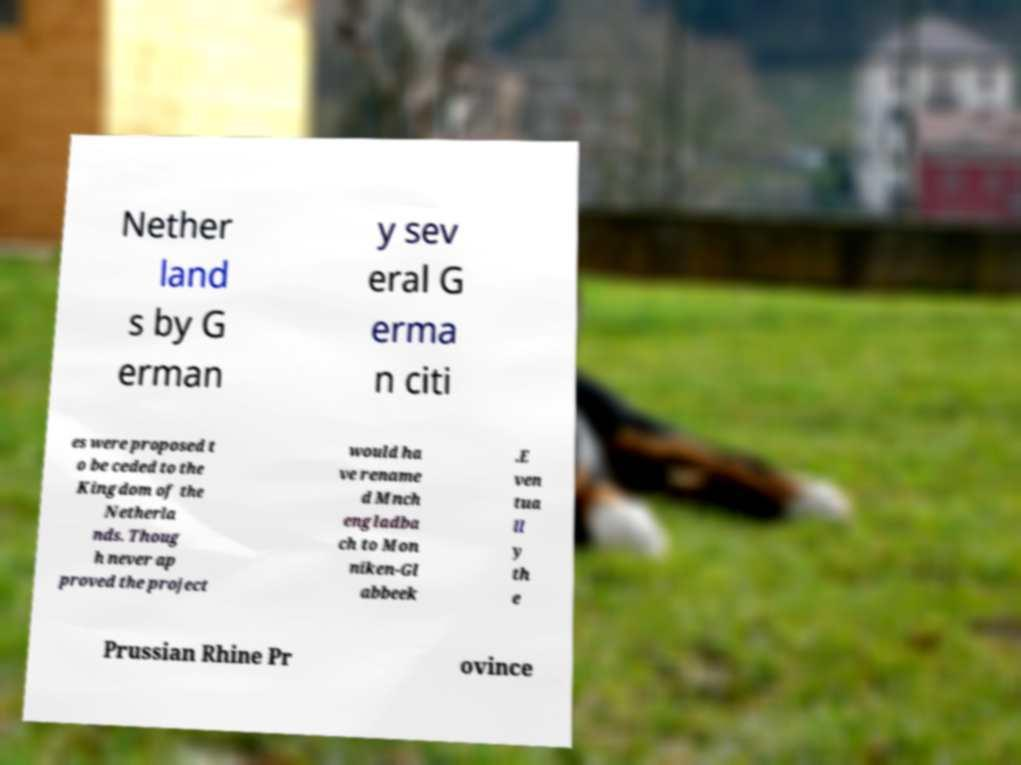Could you extract and type out the text from this image? Nether land s by G erman y sev eral G erma n citi es were proposed t o be ceded to the Kingdom of the Netherla nds. Thoug h never ap proved the project would ha ve rename d Mnch engladba ch to Mon niken-Gl abbeek .E ven tua ll y th e Prussian Rhine Pr ovince 